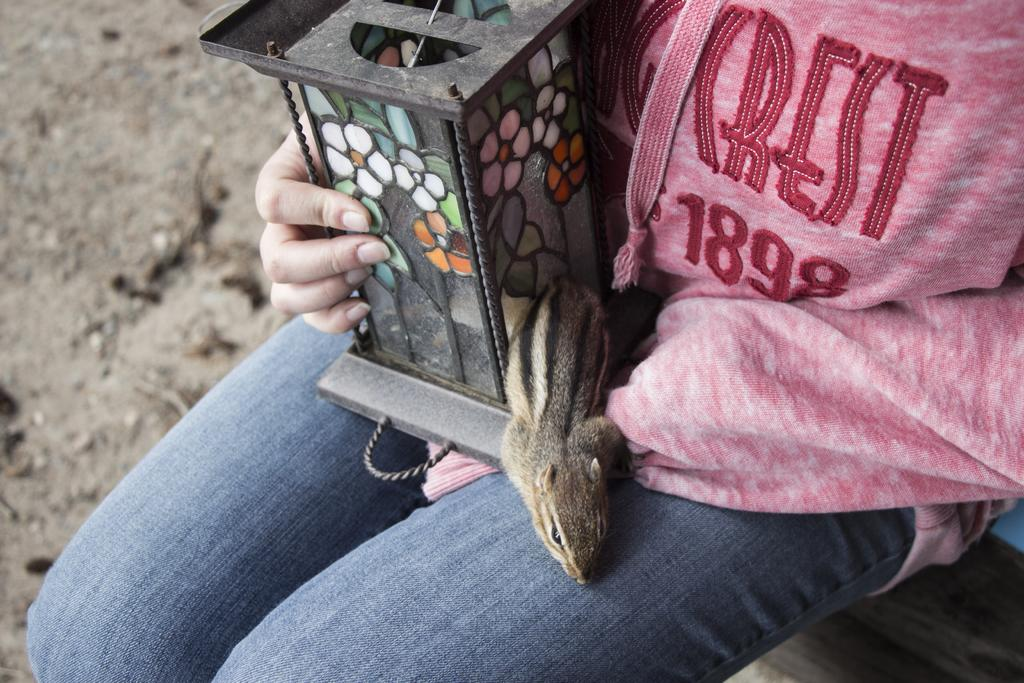What is the person in the image doing? The person is sitting in the image. What object is the person holding? The person is holding a stained glass box. What animal can be seen in the middle of the image? There is a squirrel in the middle of the image. What type of chalk is the writer using to draw on the hill in the image? There is no writer or hill present in the image, and therefore no chalk or drawing can be observed. 